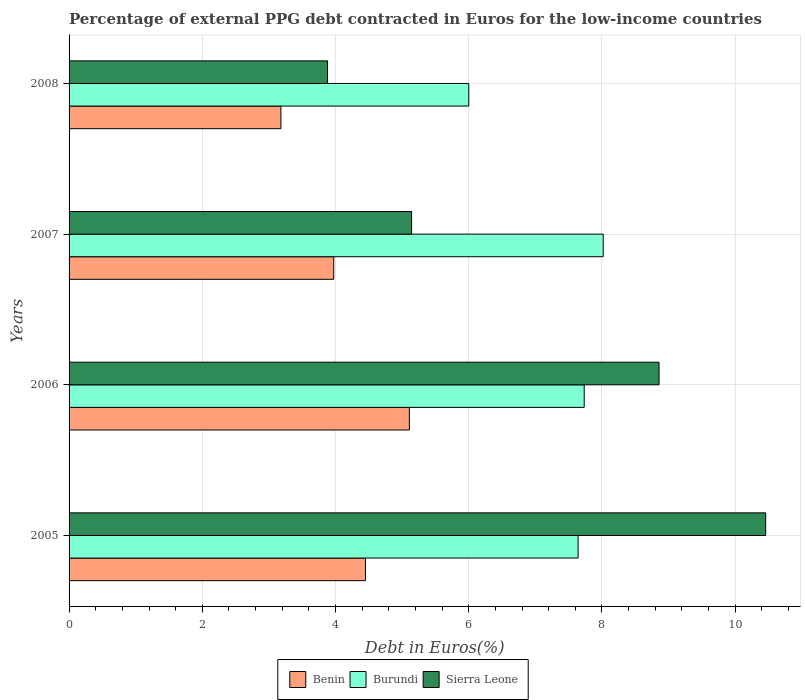How many groups of bars are there?
Make the answer very short. 4. Are the number of bars per tick equal to the number of legend labels?
Ensure brevity in your answer.  Yes. Are the number of bars on each tick of the Y-axis equal?
Offer a terse response. Yes. How many bars are there on the 1st tick from the top?
Ensure brevity in your answer.  3. What is the percentage of external PPG debt contracted in Euros in Benin in 2005?
Make the answer very short. 4.45. Across all years, what is the maximum percentage of external PPG debt contracted in Euros in Benin?
Provide a succinct answer. 5.11. Across all years, what is the minimum percentage of external PPG debt contracted in Euros in Sierra Leone?
Ensure brevity in your answer.  3.88. In which year was the percentage of external PPG debt contracted in Euros in Benin minimum?
Give a very brief answer. 2008. What is the total percentage of external PPG debt contracted in Euros in Sierra Leone in the graph?
Your response must be concise. 28.34. What is the difference between the percentage of external PPG debt contracted in Euros in Benin in 2005 and that in 2007?
Provide a short and direct response. 0.48. What is the difference between the percentage of external PPG debt contracted in Euros in Sierra Leone in 2005 and the percentage of external PPG debt contracted in Euros in Benin in 2008?
Provide a succinct answer. 7.28. What is the average percentage of external PPG debt contracted in Euros in Burundi per year?
Provide a short and direct response. 7.35. In the year 2005, what is the difference between the percentage of external PPG debt contracted in Euros in Benin and percentage of external PPG debt contracted in Euros in Sierra Leone?
Ensure brevity in your answer.  -6.01. What is the ratio of the percentage of external PPG debt contracted in Euros in Burundi in 2007 to that in 2008?
Provide a short and direct response. 1.34. Is the percentage of external PPG debt contracted in Euros in Sierra Leone in 2005 less than that in 2006?
Ensure brevity in your answer.  No. Is the difference between the percentage of external PPG debt contracted in Euros in Benin in 2006 and 2008 greater than the difference between the percentage of external PPG debt contracted in Euros in Sierra Leone in 2006 and 2008?
Make the answer very short. No. What is the difference between the highest and the second highest percentage of external PPG debt contracted in Euros in Benin?
Keep it short and to the point. 0.66. What is the difference between the highest and the lowest percentage of external PPG debt contracted in Euros in Sierra Leone?
Offer a very short reply. 6.58. In how many years, is the percentage of external PPG debt contracted in Euros in Benin greater than the average percentage of external PPG debt contracted in Euros in Benin taken over all years?
Make the answer very short. 2. What does the 1st bar from the top in 2008 represents?
Ensure brevity in your answer.  Sierra Leone. What does the 2nd bar from the bottom in 2006 represents?
Your answer should be compact. Burundi. Are all the bars in the graph horizontal?
Make the answer very short. Yes. How many years are there in the graph?
Make the answer very short. 4. What is the difference between two consecutive major ticks on the X-axis?
Your response must be concise. 2. What is the title of the graph?
Your answer should be very brief. Percentage of external PPG debt contracted in Euros for the low-income countries. Does "Qatar" appear as one of the legend labels in the graph?
Your answer should be compact. No. What is the label or title of the X-axis?
Ensure brevity in your answer.  Debt in Euros(%). What is the Debt in Euros(%) in Benin in 2005?
Your response must be concise. 4.45. What is the Debt in Euros(%) of Burundi in 2005?
Your answer should be compact. 7.64. What is the Debt in Euros(%) in Sierra Leone in 2005?
Offer a terse response. 10.46. What is the Debt in Euros(%) in Benin in 2006?
Provide a succinct answer. 5.11. What is the Debt in Euros(%) in Burundi in 2006?
Your response must be concise. 7.73. What is the Debt in Euros(%) of Sierra Leone in 2006?
Give a very brief answer. 8.86. What is the Debt in Euros(%) in Benin in 2007?
Provide a short and direct response. 3.97. What is the Debt in Euros(%) of Burundi in 2007?
Offer a very short reply. 8.02. What is the Debt in Euros(%) in Sierra Leone in 2007?
Provide a short and direct response. 5.14. What is the Debt in Euros(%) in Benin in 2008?
Provide a succinct answer. 3.18. What is the Debt in Euros(%) in Burundi in 2008?
Ensure brevity in your answer.  6. What is the Debt in Euros(%) in Sierra Leone in 2008?
Offer a terse response. 3.88. Across all years, what is the maximum Debt in Euros(%) of Benin?
Make the answer very short. 5.11. Across all years, what is the maximum Debt in Euros(%) of Burundi?
Provide a succinct answer. 8.02. Across all years, what is the maximum Debt in Euros(%) in Sierra Leone?
Make the answer very short. 10.46. Across all years, what is the minimum Debt in Euros(%) in Benin?
Your answer should be compact. 3.18. Across all years, what is the minimum Debt in Euros(%) of Burundi?
Give a very brief answer. 6. Across all years, what is the minimum Debt in Euros(%) in Sierra Leone?
Offer a very short reply. 3.88. What is the total Debt in Euros(%) of Benin in the graph?
Provide a succinct answer. 16.71. What is the total Debt in Euros(%) in Burundi in the graph?
Keep it short and to the point. 29.39. What is the total Debt in Euros(%) of Sierra Leone in the graph?
Your response must be concise. 28.34. What is the difference between the Debt in Euros(%) of Benin in 2005 and that in 2006?
Offer a very short reply. -0.66. What is the difference between the Debt in Euros(%) of Burundi in 2005 and that in 2006?
Keep it short and to the point. -0.09. What is the difference between the Debt in Euros(%) of Sierra Leone in 2005 and that in 2006?
Give a very brief answer. 1.6. What is the difference between the Debt in Euros(%) of Benin in 2005 and that in 2007?
Make the answer very short. 0.48. What is the difference between the Debt in Euros(%) in Burundi in 2005 and that in 2007?
Offer a very short reply. -0.38. What is the difference between the Debt in Euros(%) in Sierra Leone in 2005 and that in 2007?
Provide a succinct answer. 5.32. What is the difference between the Debt in Euros(%) in Benin in 2005 and that in 2008?
Offer a very short reply. 1.27. What is the difference between the Debt in Euros(%) in Burundi in 2005 and that in 2008?
Give a very brief answer. 1.64. What is the difference between the Debt in Euros(%) in Sierra Leone in 2005 and that in 2008?
Your answer should be very brief. 6.58. What is the difference between the Debt in Euros(%) of Benin in 2006 and that in 2007?
Provide a succinct answer. 1.14. What is the difference between the Debt in Euros(%) in Burundi in 2006 and that in 2007?
Give a very brief answer. -0.29. What is the difference between the Debt in Euros(%) of Sierra Leone in 2006 and that in 2007?
Make the answer very short. 3.71. What is the difference between the Debt in Euros(%) of Benin in 2006 and that in 2008?
Keep it short and to the point. 1.93. What is the difference between the Debt in Euros(%) of Burundi in 2006 and that in 2008?
Offer a very short reply. 1.73. What is the difference between the Debt in Euros(%) of Sierra Leone in 2006 and that in 2008?
Your answer should be compact. 4.98. What is the difference between the Debt in Euros(%) in Benin in 2007 and that in 2008?
Your answer should be very brief. 0.79. What is the difference between the Debt in Euros(%) in Burundi in 2007 and that in 2008?
Your answer should be compact. 2.02. What is the difference between the Debt in Euros(%) in Sierra Leone in 2007 and that in 2008?
Offer a very short reply. 1.26. What is the difference between the Debt in Euros(%) of Benin in 2005 and the Debt in Euros(%) of Burundi in 2006?
Provide a succinct answer. -3.28. What is the difference between the Debt in Euros(%) in Benin in 2005 and the Debt in Euros(%) in Sierra Leone in 2006?
Keep it short and to the point. -4.41. What is the difference between the Debt in Euros(%) of Burundi in 2005 and the Debt in Euros(%) of Sierra Leone in 2006?
Ensure brevity in your answer.  -1.22. What is the difference between the Debt in Euros(%) in Benin in 2005 and the Debt in Euros(%) in Burundi in 2007?
Your answer should be very brief. -3.57. What is the difference between the Debt in Euros(%) in Benin in 2005 and the Debt in Euros(%) in Sierra Leone in 2007?
Your response must be concise. -0.69. What is the difference between the Debt in Euros(%) in Burundi in 2005 and the Debt in Euros(%) in Sierra Leone in 2007?
Make the answer very short. 2.5. What is the difference between the Debt in Euros(%) in Benin in 2005 and the Debt in Euros(%) in Burundi in 2008?
Your answer should be compact. -1.55. What is the difference between the Debt in Euros(%) of Benin in 2005 and the Debt in Euros(%) of Sierra Leone in 2008?
Offer a terse response. 0.57. What is the difference between the Debt in Euros(%) in Burundi in 2005 and the Debt in Euros(%) in Sierra Leone in 2008?
Offer a very short reply. 3.76. What is the difference between the Debt in Euros(%) in Benin in 2006 and the Debt in Euros(%) in Burundi in 2007?
Make the answer very short. -2.91. What is the difference between the Debt in Euros(%) of Benin in 2006 and the Debt in Euros(%) of Sierra Leone in 2007?
Offer a very short reply. -0.03. What is the difference between the Debt in Euros(%) of Burundi in 2006 and the Debt in Euros(%) of Sierra Leone in 2007?
Offer a very short reply. 2.59. What is the difference between the Debt in Euros(%) of Benin in 2006 and the Debt in Euros(%) of Burundi in 2008?
Your answer should be very brief. -0.89. What is the difference between the Debt in Euros(%) of Benin in 2006 and the Debt in Euros(%) of Sierra Leone in 2008?
Your answer should be compact. 1.23. What is the difference between the Debt in Euros(%) in Burundi in 2006 and the Debt in Euros(%) in Sierra Leone in 2008?
Offer a terse response. 3.85. What is the difference between the Debt in Euros(%) of Benin in 2007 and the Debt in Euros(%) of Burundi in 2008?
Provide a succinct answer. -2.03. What is the difference between the Debt in Euros(%) in Benin in 2007 and the Debt in Euros(%) in Sierra Leone in 2008?
Your answer should be compact. 0.09. What is the difference between the Debt in Euros(%) in Burundi in 2007 and the Debt in Euros(%) in Sierra Leone in 2008?
Your response must be concise. 4.14. What is the average Debt in Euros(%) in Benin per year?
Provide a succinct answer. 4.18. What is the average Debt in Euros(%) in Burundi per year?
Offer a terse response. 7.35. What is the average Debt in Euros(%) in Sierra Leone per year?
Your answer should be compact. 7.08. In the year 2005, what is the difference between the Debt in Euros(%) in Benin and Debt in Euros(%) in Burundi?
Keep it short and to the point. -3.19. In the year 2005, what is the difference between the Debt in Euros(%) in Benin and Debt in Euros(%) in Sierra Leone?
Provide a short and direct response. -6.01. In the year 2005, what is the difference between the Debt in Euros(%) in Burundi and Debt in Euros(%) in Sierra Leone?
Ensure brevity in your answer.  -2.82. In the year 2006, what is the difference between the Debt in Euros(%) in Benin and Debt in Euros(%) in Burundi?
Give a very brief answer. -2.63. In the year 2006, what is the difference between the Debt in Euros(%) of Benin and Debt in Euros(%) of Sierra Leone?
Offer a very short reply. -3.75. In the year 2006, what is the difference between the Debt in Euros(%) in Burundi and Debt in Euros(%) in Sierra Leone?
Offer a very short reply. -1.12. In the year 2007, what is the difference between the Debt in Euros(%) of Benin and Debt in Euros(%) of Burundi?
Your answer should be very brief. -4.05. In the year 2007, what is the difference between the Debt in Euros(%) in Benin and Debt in Euros(%) in Sierra Leone?
Make the answer very short. -1.17. In the year 2007, what is the difference between the Debt in Euros(%) in Burundi and Debt in Euros(%) in Sierra Leone?
Offer a very short reply. 2.88. In the year 2008, what is the difference between the Debt in Euros(%) in Benin and Debt in Euros(%) in Burundi?
Your answer should be very brief. -2.82. In the year 2008, what is the difference between the Debt in Euros(%) of Benin and Debt in Euros(%) of Sierra Leone?
Offer a terse response. -0.7. In the year 2008, what is the difference between the Debt in Euros(%) in Burundi and Debt in Euros(%) in Sierra Leone?
Provide a short and direct response. 2.12. What is the ratio of the Debt in Euros(%) in Benin in 2005 to that in 2006?
Your response must be concise. 0.87. What is the ratio of the Debt in Euros(%) in Burundi in 2005 to that in 2006?
Ensure brevity in your answer.  0.99. What is the ratio of the Debt in Euros(%) in Sierra Leone in 2005 to that in 2006?
Ensure brevity in your answer.  1.18. What is the ratio of the Debt in Euros(%) of Benin in 2005 to that in 2007?
Provide a succinct answer. 1.12. What is the ratio of the Debt in Euros(%) of Burundi in 2005 to that in 2007?
Your response must be concise. 0.95. What is the ratio of the Debt in Euros(%) of Sierra Leone in 2005 to that in 2007?
Your answer should be very brief. 2.03. What is the ratio of the Debt in Euros(%) in Benin in 2005 to that in 2008?
Your response must be concise. 1.4. What is the ratio of the Debt in Euros(%) of Burundi in 2005 to that in 2008?
Provide a short and direct response. 1.27. What is the ratio of the Debt in Euros(%) of Sierra Leone in 2005 to that in 2008?
Provide a short and direct response. 2.69. What is the ratio of the Debt in Euros(%) of Benin in 2006 to that in 2007?
Provide a succinct answer. 1.29. What is the ratio of the Debt in Euros(%) in Burundi in 2006 to that in 2007?
Offer a terse response. 0.96. What is the ratio of the Debt in Euros(%) in Sierra Leone in 2006 to that in 2007?
Your answer should be very brief. 1.72. What is the ratio of the Debt in Euros(%) of Benin in 2006 to that in 2008?
Your response must be concise. 1.61. What is the ratio of the Debt in Euros(%) of Burundi in 2006 to that in 2008?
Your answer should be compact. 1.29. What is the ratio of the Debt in Euros(%) of Sierra Leone in 2006 to that in 2008?
Ensure brevity in your answer.  2.28. What is the ratio of the Debt in Euros(%) of Benin in 2007 to that in 2008?
Keep it short and to the point. 1.25. What is the ratio of the Debt in Euros(%) in Burundi in 2007 to that in 2008?
Provide a short and direct response. 1.34. What is the ratio of the Debt in Euros(%) of Sierra Leone in 2007 to that in 2008?
Ensure brevity in your answer.  1.33. What is the difference between the highest and the second highest Debt in Euros(%) of Benin?
Keep it short and to the point. 0.66. What is the difference between the highest and the second highest Debt in Euros(%) of Burundi?
Give a very brief answer. 0.29. What is the difference between the highest and the second highest Debt in Euros(%) of Sierra Leone?
Your answer should be compact. 1.6. What is the difference between the highest and the lowest Debt in Euros(%) in Benin?
Provide a short and direct response. 1.93. What is the difference between the highest and the lowest Debt in Euros(%) in Burundi?
Provide a short and direct response. 2.02. What is the difference between the highest and the lowest Debt in Euros(%) of Sierra Leone?
Your answer should be compact. 6.58. 